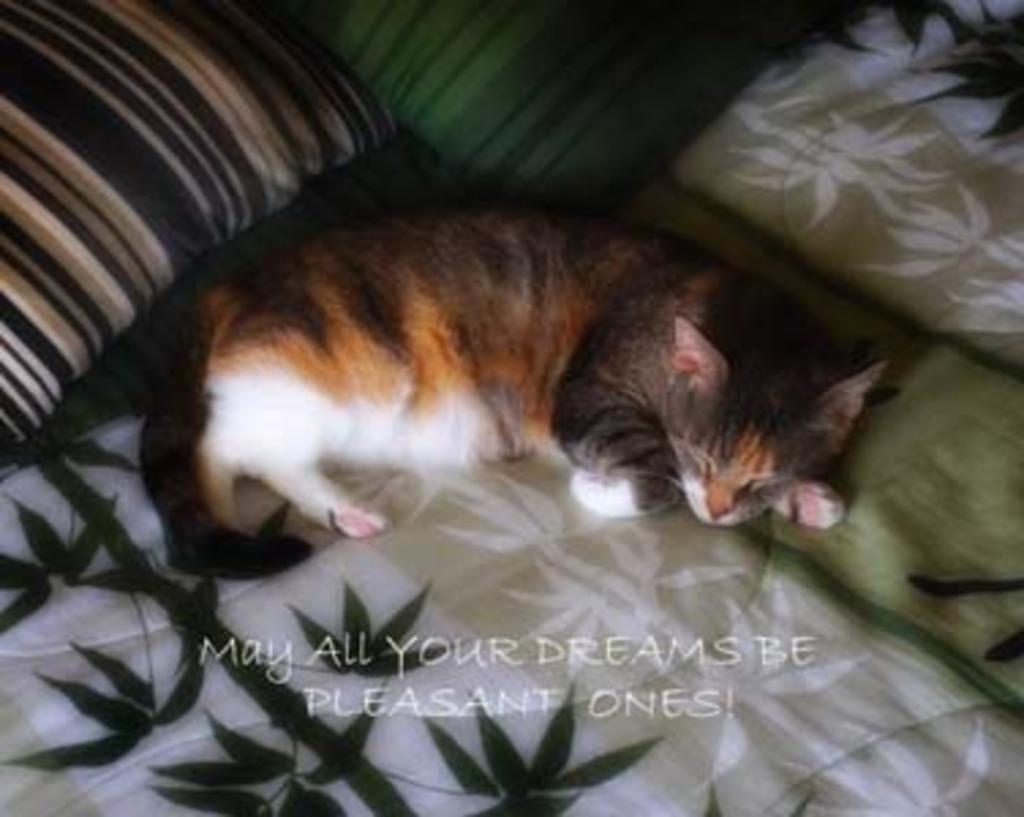Can you describe this image briefly? As we can see in the image there are pillows and a cat on bed. 